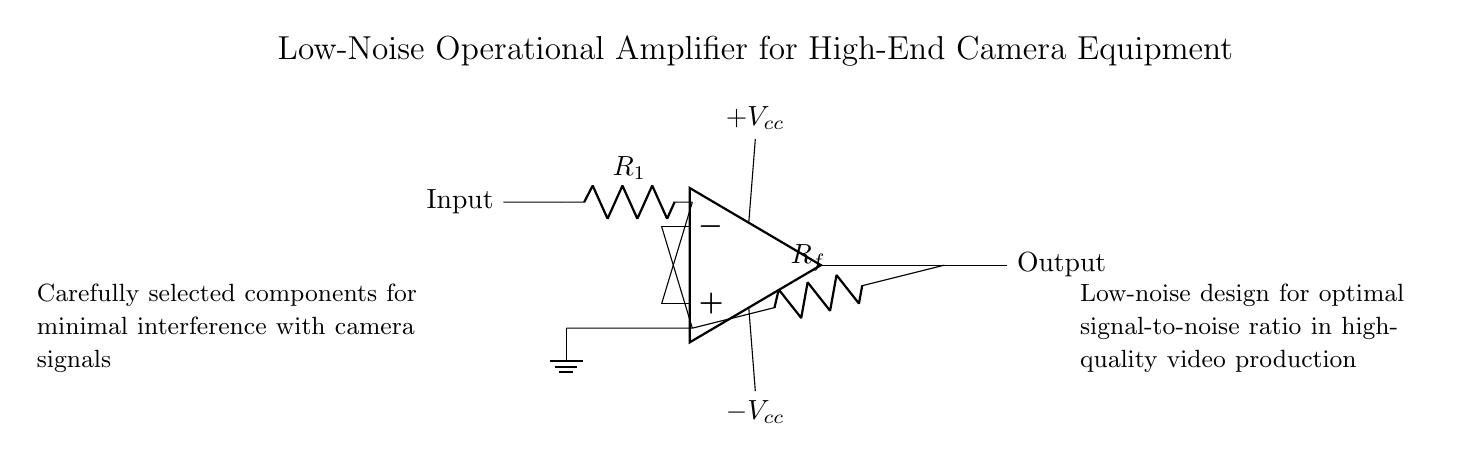What is the type of amplifier shown in the circuit? The circuit displays a low-noise operational amplifier, which is indicated by the op-amp symbol.
Answer: low-noise operational amplifier What are the values of the feedback resistor? The feedback resistor is labeled as R_f in the circuit diagram. The value is not specified, but it is identified in the circuit.
Answer: R_f What is the voltage supply configuration for this amplifier? The amplifier uses a dual supply configuration, as it shows both a positive and a negative voltage supply with +V_cc and -V_cc respectively.
Answer: dual supply What is the purpose of the resistor labeled R_1? R_1 is used to set the input impedance and gain in the circuit, which is essential for signal processing in amplifiers.
Answer: input impedance How does the circuit minimize noise during operation? The circuit is designed with low-noise components and connections to ensure that the signal-to-noise ratio is optimized, which is crucial for high-quality video.
Answer: low-noise components What is the expected output characteristic of this amplifier in terms of signal quality? The expected output should have improved quality and clarity due to the low-noise design, allowing for a better representation of the input signal.
Answer: improved quality What component connects the inverting input to the output? The inverting input is connected to the output through the feedback resistor R_f, which is essential for the operation of the feedback mechanism.
Answer: feedback resistor R_f 